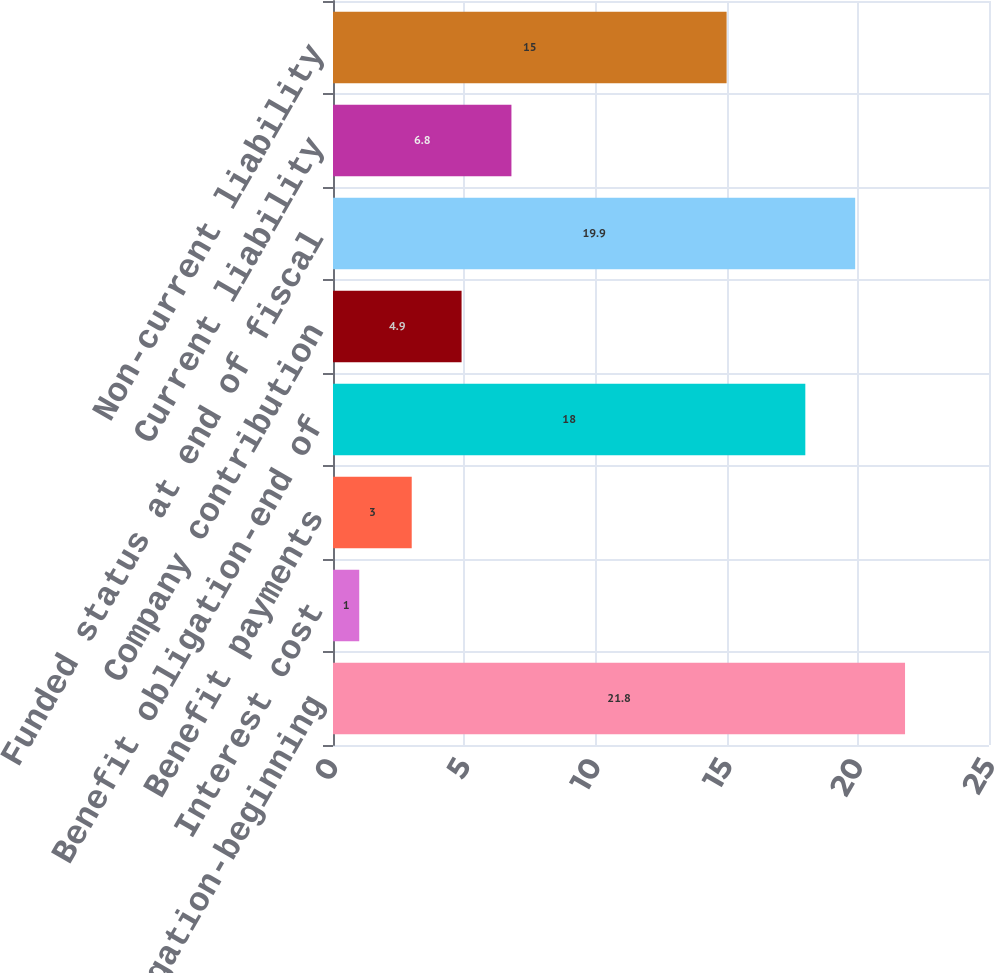Convert chart. <chart><loc_0><loc_0><loc_500><loc_500><bar_chart><fcel>Benefit obligation-beginning<fcel>Interest cost<fcel>Benefit payments<fcel>Benefit obligation-end of<fcel>Company contribution<fcel>Funded status at end of fiscal<fcel>Current liability<fcel>Non-current liability<nl><fcel>21.8<fcel>1<fcel>3<fcel>18<fcel>4.9<fcel>19.9<fcel>6.8<fcel>15<nl></chart> 